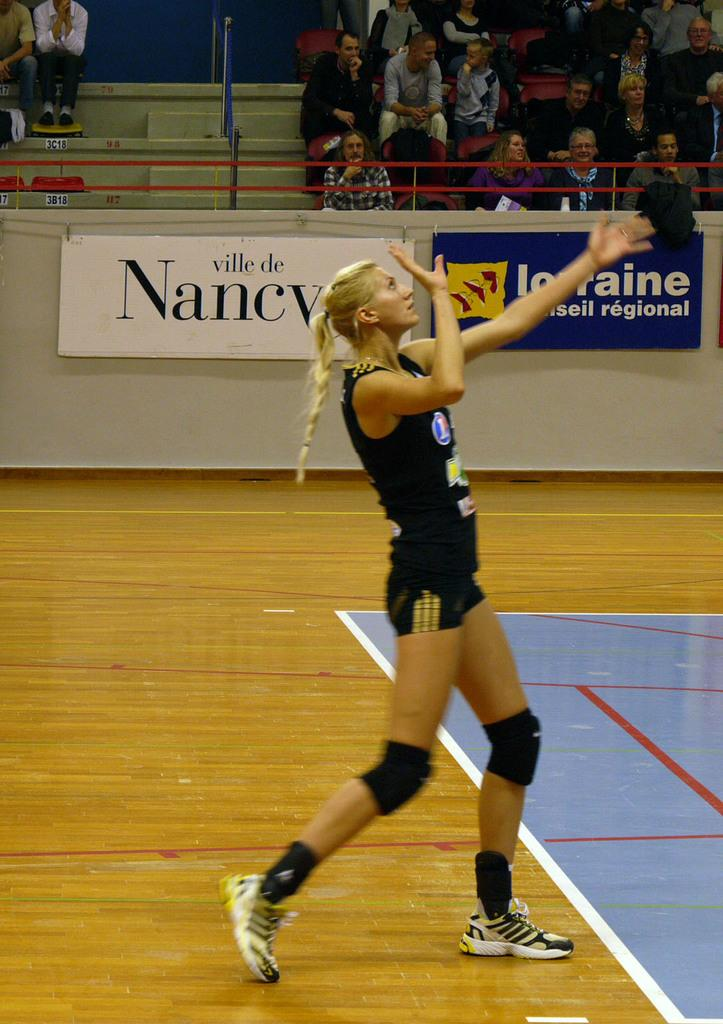Who is the main subject in the image? There is a woman in the image. What is the woman doing in the image? The woman is standing. What is the woman wearing in the image? The woman is wearing a black dress. What can be seen in the background of the image? There are banners and people present in the background of the image. What architectural feature is visible in the image? There is a fence in the image. How many rings are visible on the woman's fingers in the image? There is no information about rings on the woman's fingers in the image. What type of root is growing near the fence in the image? There is no root visible in the image; only the fence is mentioned. 